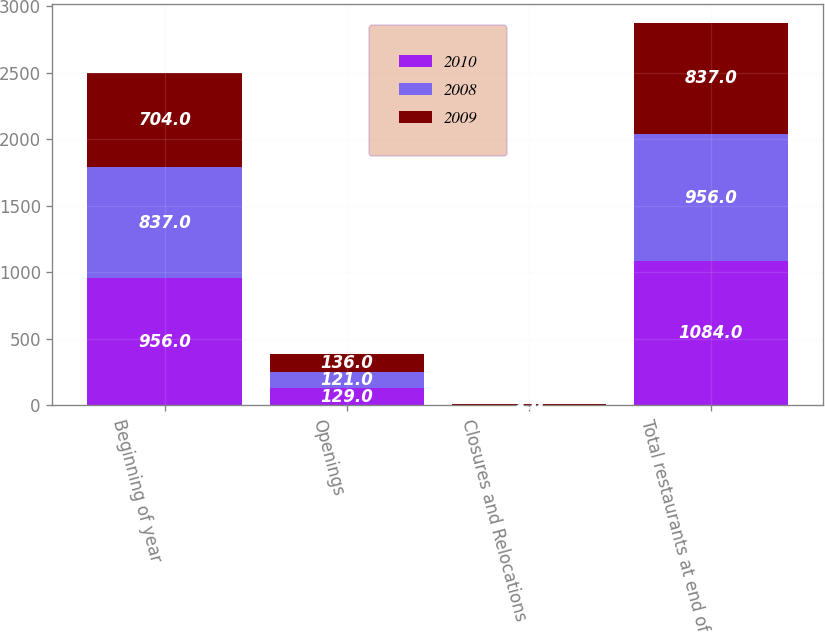Convert chart. <chart><loc_0><loc_0><loc_500><loc_500><stacked_bar_chart><ecel><fcel>Beginning of year<fcel>Openings<fcel>Closures and Relocations<fcel>Total restaurants at end of<nl><fcel>2010<fcel>956<fcel>129<fcel>1<fcel>1084<nl><fcel>2008<fcel>837<fcel>121<fcel>2<fcel>956<nl><fcel>2009<fcel>704<fcel>136<fcel>3<fcel>837<nl></chart> 